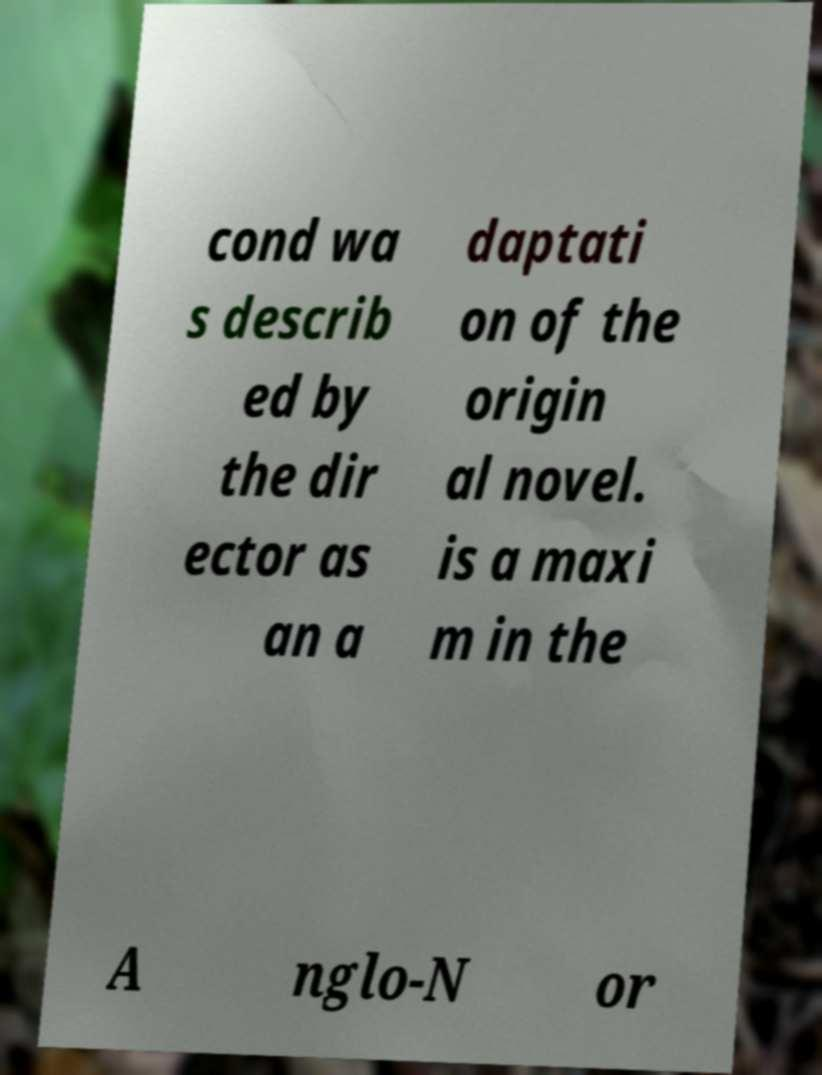I need the written content from this picture converted into text. Can you do that? cond wa s describ ed by the dir ector as an a daptati on of the origin al novel. is a maxi m in the A nglo-N or 